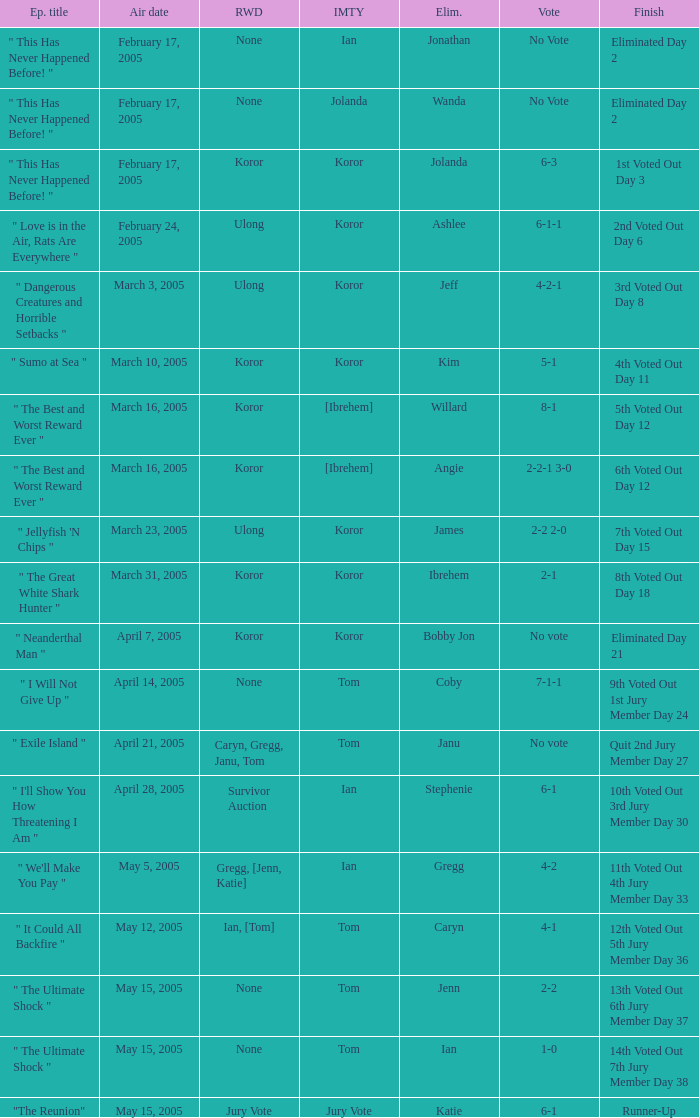What is the name of the episode in which Jenn is eliminated? " The Ultimate Shock ". 